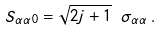Convert formula to latex. <formula><loc_0><loc_0><loc_500><loc_500>S _ { \alpha \alpha 0 } = \sqrt { 2 j + 1 } \ \sigma _ { \alpha \alpha } \, .</formula> 